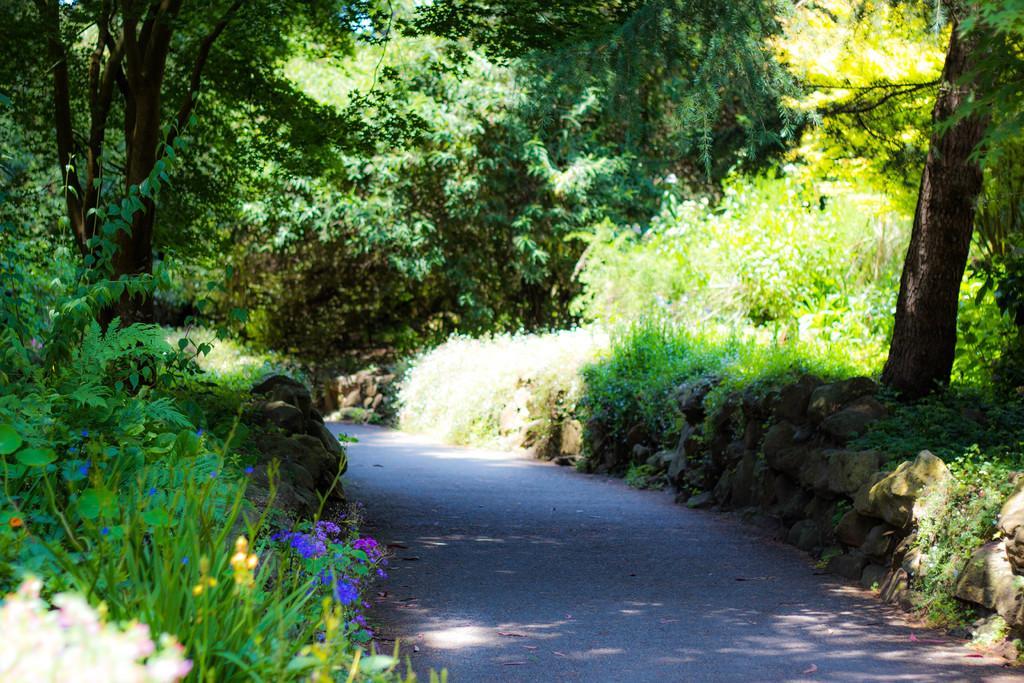How would you summarize this image in a sentence or two? This picture might be taken from outside of the city and it is sunny. In this image, on the right side, we can see some trees, plants. On the left side, we can also see some stones, plants, flowers, trees. In the background, there are some trees, at the bottom there is a road. 